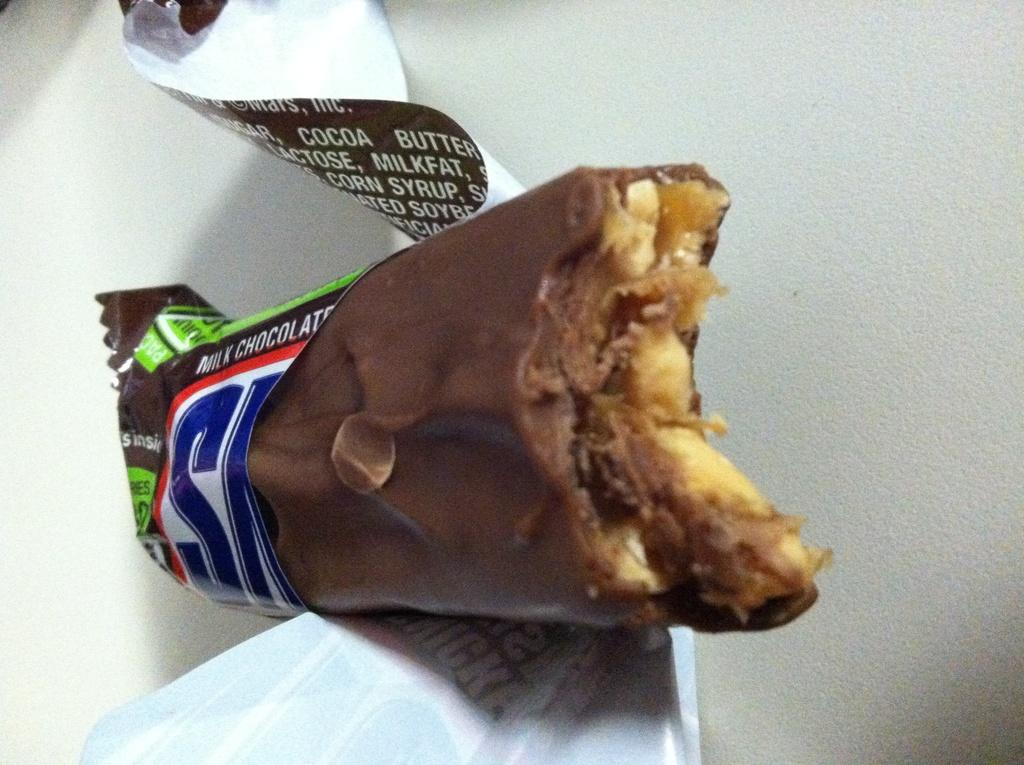What is the main subject of the image? The main subject of the image is a chocolate. What can be said about the color of the chocolate? The chocolate is brown in color. How does the chocolate contribute to the ongoing discussion in the image? There is no discussion present in the image, and the chocolate is not contributing to any conversation. 